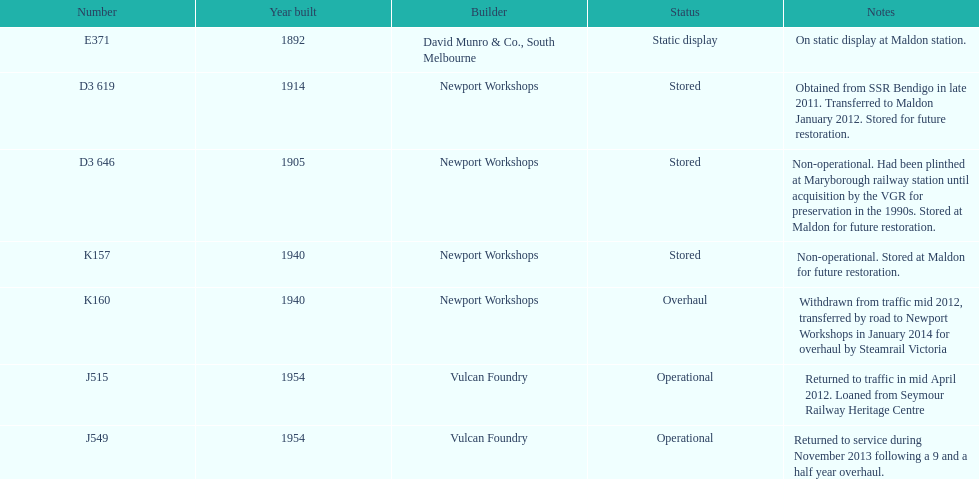What are the sole trains that continue to operate? J515, J549. 